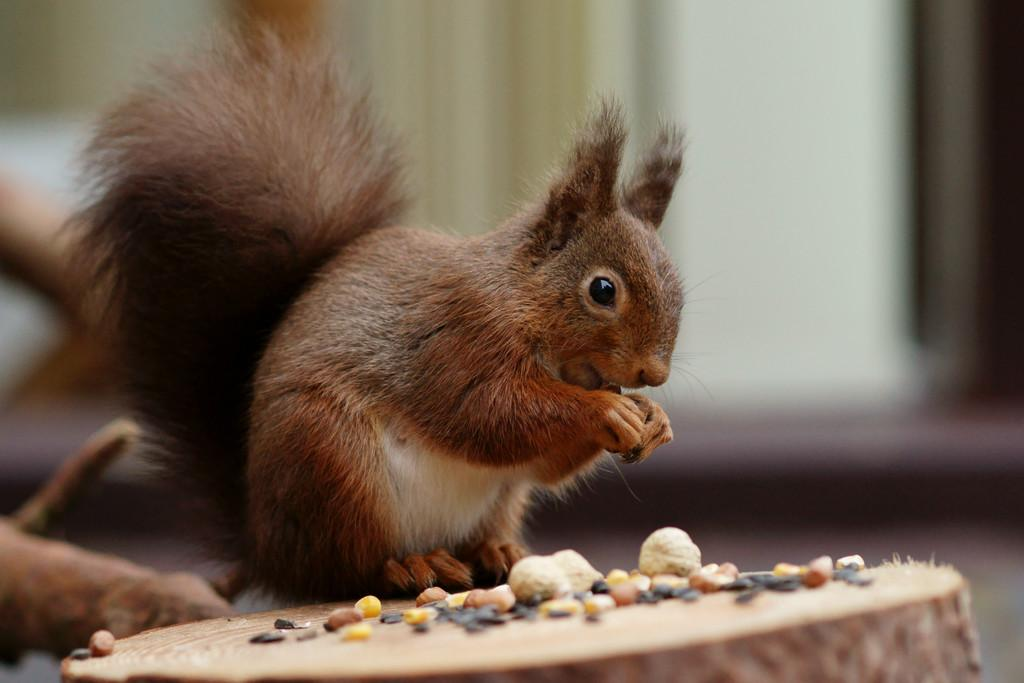What animal can be seen in the picture? There is a squirrel in the picture. What is the squirrel holding in its hands? The squirrel is holding a nut. On what surface is the squirrel standing? The squirrel is standing on wood. What other objects are visible near the squirrel? There are small stones and nuts beside the squirrel. How would you describe the background of the image? The background of the image is blurred. What type of knot is the squirrel trying to untie in the image? There is no knot present in the image; the squirrel is holding a nut. Is the squirrel lying on a bed in the image? No, the squirrel is standing on wood, not a bed. 